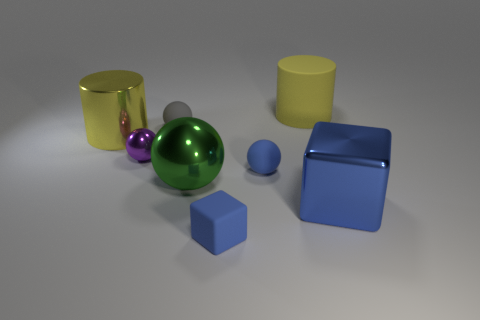Add 1 large green metal objects. How many objects exist? 9 Subtract all small balls. How many balls are left? 1 Subtract all green balls. How many balls are left? 3 Subtract all cylinders. How many objects are left? 6 Subtract 2 cylinders. How many cylinders are left? 0 Subtract all gray cylinders. Subtract all gray spheres. How many cylinders are left? 2 Subtract all purple cylinders. How many blue spheres are left? 1 Subtract all big blue cubes. Subtract all big metal objects. How many objects are left? 4 Add 2 big matte objects. How many big matte objects are left? 3 Add 3 blue things. How many blue things exist? 6 